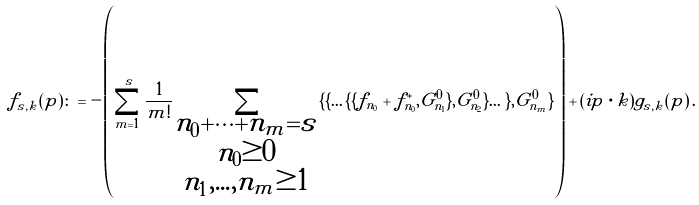<formula> <loc_0><loc_0><loc_500><loc_500>f _ { s , k } ( p ) \colon = - \left ( \sum _ { m = 1 } ^ { s } \frac { 1 } { m ! } \sum _ { \substack { n _ { 0 } + \dots + n _ { m } = s \\ n _ { 0 } \geq 0 \\ n _ { 1 } , \dots , n _ { m } \geq 1 } } \{ \{ \dots \{ \{ f _ { n _ { 0 } } + f _ { n _ { 0 } } ^ { * } , G ^ { 0 } _ { n _ { 1 } } \} , G ^ { 0 } _ { n _ { 2 } } \} \dots \} , G ^ { 0 } _ { n _ { m } } \} \right ) + ( i p \cdot k ) g _ { s , k } ( p ) \, .</formula> 